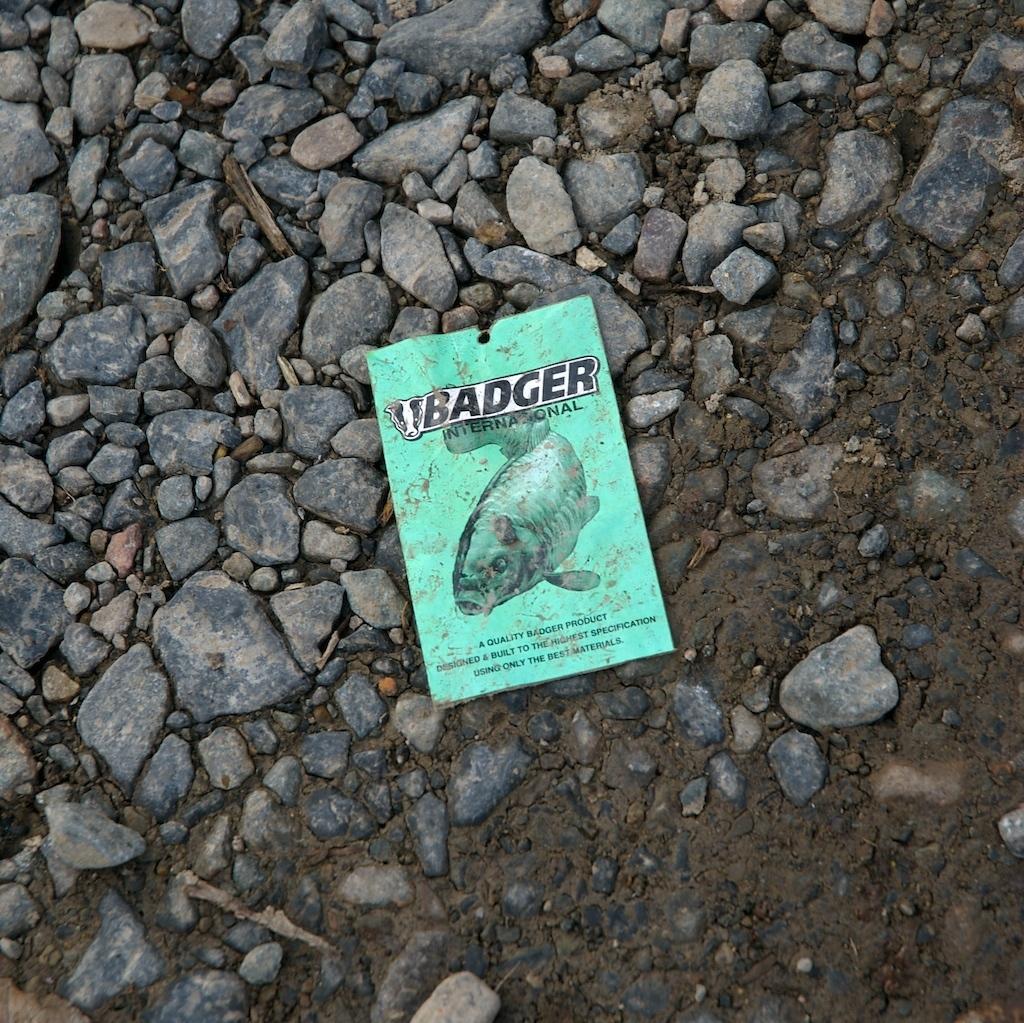Describe this image in one or two sentences. In this image there is a poster with text and a picture of a fish is lying on the stones. 